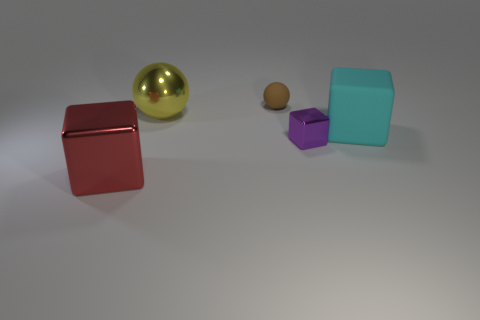There is a big red object that is made of the same material as the large yellow ball; what is its shape?
Provide a succinct answer. Cube. How many big yellow objects are the same shape as the small brown object?
Your response must be concise. 1. What material is the yellow object?
Give a very brief answer. Metal. What number of cylinders are yellow things or tiny things?
Offer a terse response. 0. What is the color of the matte object on the left side of the tiny metal object?
Ensure brevity in your answer.  Brown. How many shiny balls have the same size as the matte cube?
Ensure brevity in your answer.  1. There is a large metallic thing that is behind the large red shiny thing; is its shape the same as the big object in front of the cyan block?
Keep it short and to the point. No. What material is the big object to the right of the sphere on the right side of the metal object that is behind the big cyan cube?
Provide a succinct answer. Rubber. What shape is the cyan object that is the same size as the red metallic object?
Offer a terse response. Cube. What size is the red block?
Offer a very short reply. Large. 